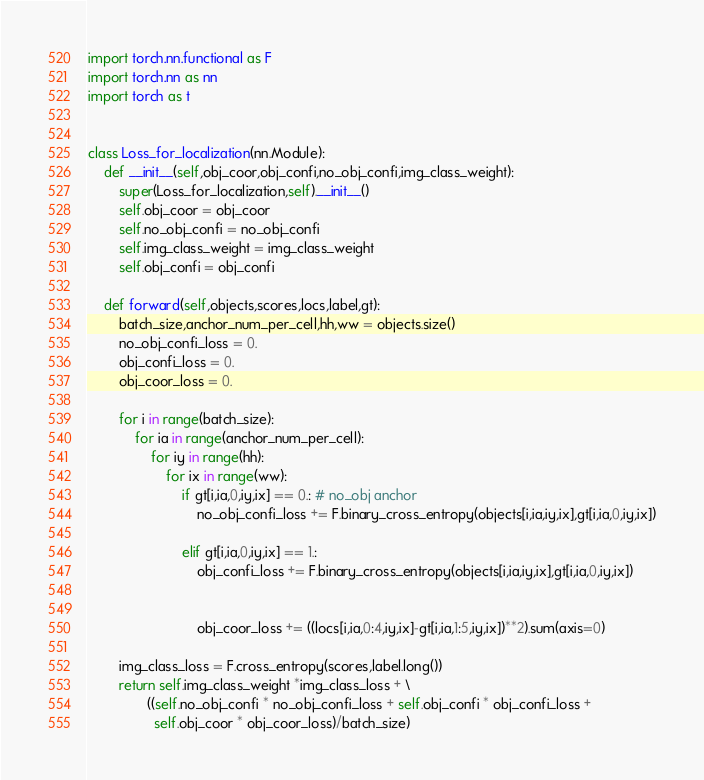Convert code to text. <code><loc_0><loc_0><loc_500><loc_500><_Python_>import torch.nn.functional as F
import torch.nn as nn
import torch as t


class Loss_for_localization(nn.Module):
    def __init__(self,obj_coor,obj_confi,no_obj_confi,img_class_weight):
        super(Loss_for_localization,self).__init__()
        self.obj_coor = obj_coor
        self.no_obj_confi = no_obj_confi
        self.img_class_weight = img_class_weight
        self.obj_confi = obj_confi

    def forward(self,objects,scores,locs,label,gt):
        batch_size,anchor_num_per_cell,hh,ww = objects.size()
        no_obj_confi_loss = 0.
        obj_confi_loss = 0.
        obj_coor_loss = 0.

        for i in range(batch_size):
            for ia in range(anchor_num_per_cell):
                for iy in range(hh):
                    for ix in range(ww):
                        if gt[i,ia,0,iy,ix] == 0.: # no_obj anchor
                            no_obj_confi_loss += F.binary_cross_entropy(objects[i,ia,iy,ix],gt[i,ia,0,iy,ix])

                        elif gt[i,ia,0,iy,ix] == 1.:
                            obj_confi_loss += F.binary_cross_entropy(objects[i,ia,iy,ix],gt[i,ia,0,iy,ix])


                            obj_coor_loss += ((locs[i,ia,0:4,iy,ix]-gt[i,ia,1:5,iy,ix])**2).sum(axis=0)

        img_class_loss = F.cross_entropy(scores,label.long())
        return self.img_class_weight *img_class_loss + \
               ((self.no_obj_confi * no_obj_confi_loss + self.obj_confi * obj_confi_loss +
                 self.obj_coor * obj_coor_loss)/batch_size)</code> 